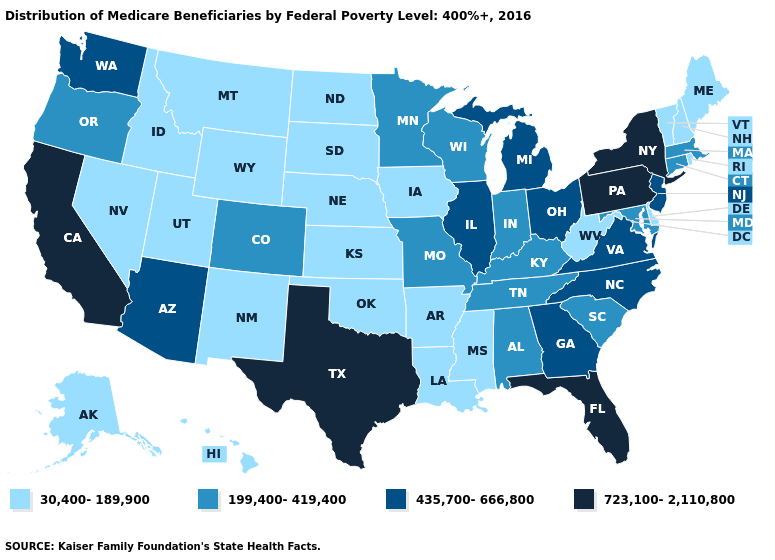What is the lowest value in the Northeast?
Give a very brief answer. 30,400-189,900. Among the states that border Nevada , which have the lowest value?
Be succinct. Idaho, Utah. Among the states that border Delaware , which have the highest value?
Answer briefly. Pennsylvania. What is the value of Arizona?
Write a very short answer. 435,700-666,800. What is the value of Illinois?
Short answer required. 435,700-666,800. Does the map have missing data?
Answer briefly. No. What is the value of Colorado?
Write a very short answer. 199,400-419,400. Among the states that border Pennsylvania , does Maryland have the highest value?
Answer briefly. No. Does the first symbol in the legend represent the smallest category?
Give a very brief answer. Yes. Does Massachusetts have the same value as Alabama?
Concise answer only. Yes. Which states have the lowest value in the West?
Give a very brief answer. Alaska, Hawaii, Idaho, Montana, Nevada, New Mexico, Utah, Wyoming. What is the value of New York?
Keep it brief. 723,100-2,110,800. Which states have the highest value in the USA?
Give a very brief answer. California, Florida, New York, Pennsylvania, Texas. Name the states that have a value in the range 723,100-2,110,800?
Concise answer only. California, Florida, New York, Pennsylvania, Texas. Among the states that border Massachusetts , does Connecticut have the highest value?
Answer briefly. No. 